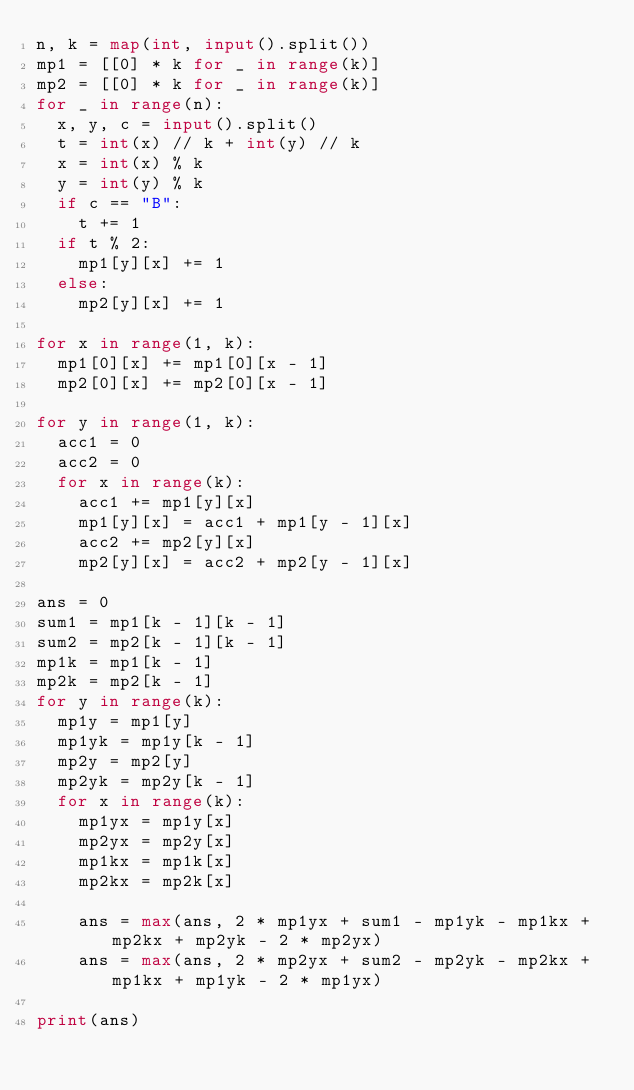Convert code to text. <code><loc_0><loc_0><loc_500><loc_500><_Python_>n, k = map(int, input().split())
mp1 = [[0] * k for _ in range(k)]
mp2 = [[0] * k for _ in range(k)]
for _ in range(n):
  x, y, c = input().split()
  t = int(x) // k + int(y) // k
  x = int(x) % k
  y = int(y) % k
  if c == "B":
    t += 1
  if t % 2:
    mp1[y][x] += 1
  else:
    mp2[y][x] += 1

for x in range(1, k):
  mp1[0][x] += mp1[0][x - 1]
  mp2[0][x] += mp2[0][x - 1]

for y in range(1, k):
  acc1 = 0
  acc2 = 0
  for x in range(k):
    acc1 += mp1[y][x]
    mp1[y][x] = acc1 + mp1[y - 1][x]
    acc2 += mp2[y][x]
    mp2[y][x] = acc2 + mp2[y - 1][x]

ans = 0
sum1 = mp1[k - 1][k - 1]
sum2 = mp2[k - 1][k - 1]
mp1k = mp1[k - 1]
mp2k = mp2[k - 1]
for y in range(k):
  mp1y = mp1[y]
  mp1yk = mp1y[k - 1]
  mp2y = mp2[y]
  mp2yk = mp2y[k - 1]
  for x in range(k):
    mp1yx = mp1y[x]
    mp2yx = mp2y[x]
    mp1kx = mp1k[x]
    mp2kx = mp2k[x]

    ans = max(ans, 2 * mp1yx + sum1 - mp1yk - mp1kx + mp2kx + mp2yk - 2 * mp2yx)
    ans = max(ans, 2 * mp2yx + sum2 - mp2yk - mp2kx + mp1kx + mp1yk - 2 * mp1yx)

print(ans)</code> 